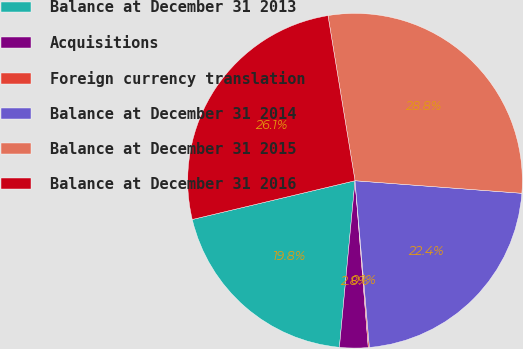Convert chart. <chart><loc_0><loc_0><loc_500><loc_500><pie_chart><fcel>Balance at December 31 2013<fcel>Acquisitions<fcel>Foreign currency translation<fcel>Balance at December 31 2014<fcel>Balance at December 31 2015<fcel>Balance at December 31 2016<nl><fcel>19.79%<fcel>2.75%<fcel>0.11%<fcel>22.43%<fcel>28.78%<fcel>26.14%<nl></chart> 